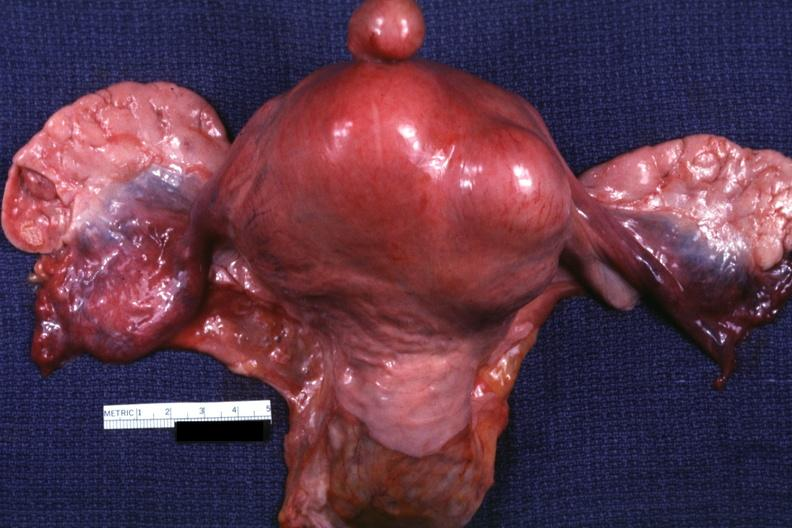s angiogram a good example one pedunculated myoma?
Answer the question using a single word or phrase. No 